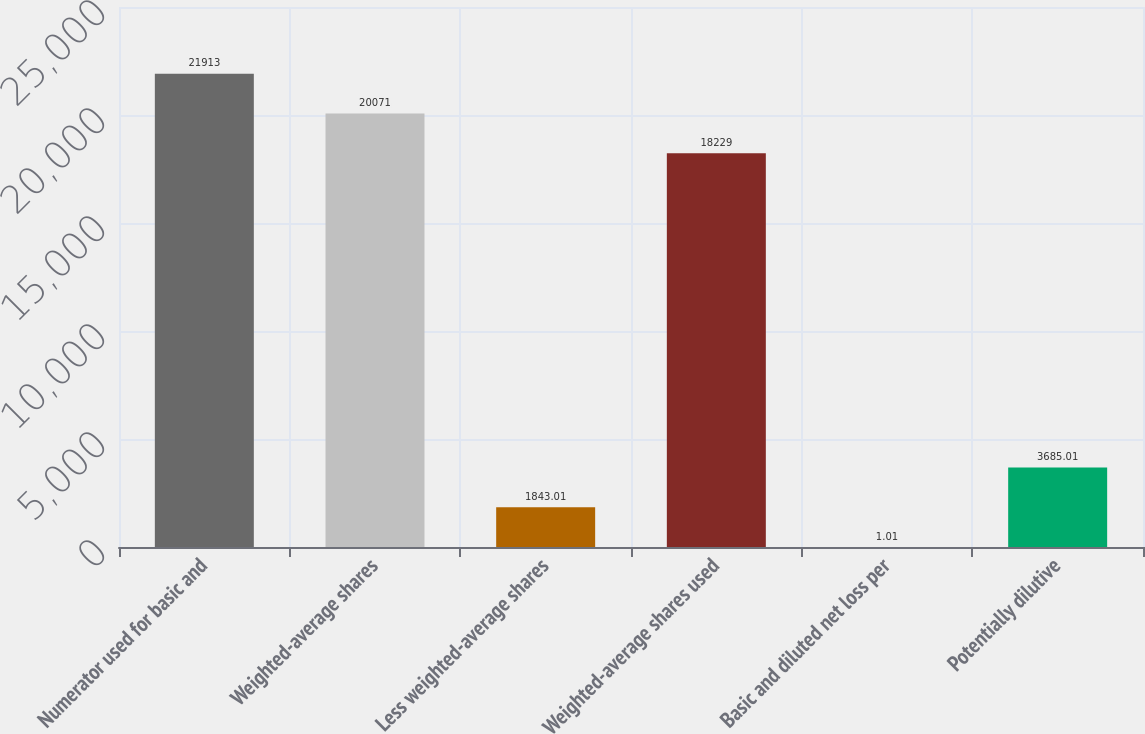<chart> <loc_0><loc_0><loc_500><loc_500><bar_chart><fcel>Numerator used for basic and<fcel>Weighted-average shares<fcel>Less weighted-average shares<fcel>Weighted-average shares used<fcel>Basic and diluted net loss per<fcel>Potentially dilutive<nl><fcel>21913<fcel>20071<fcel>1843.01<fcel>18229<fcel>1.01<fcel>3685.01<nl></chart> 